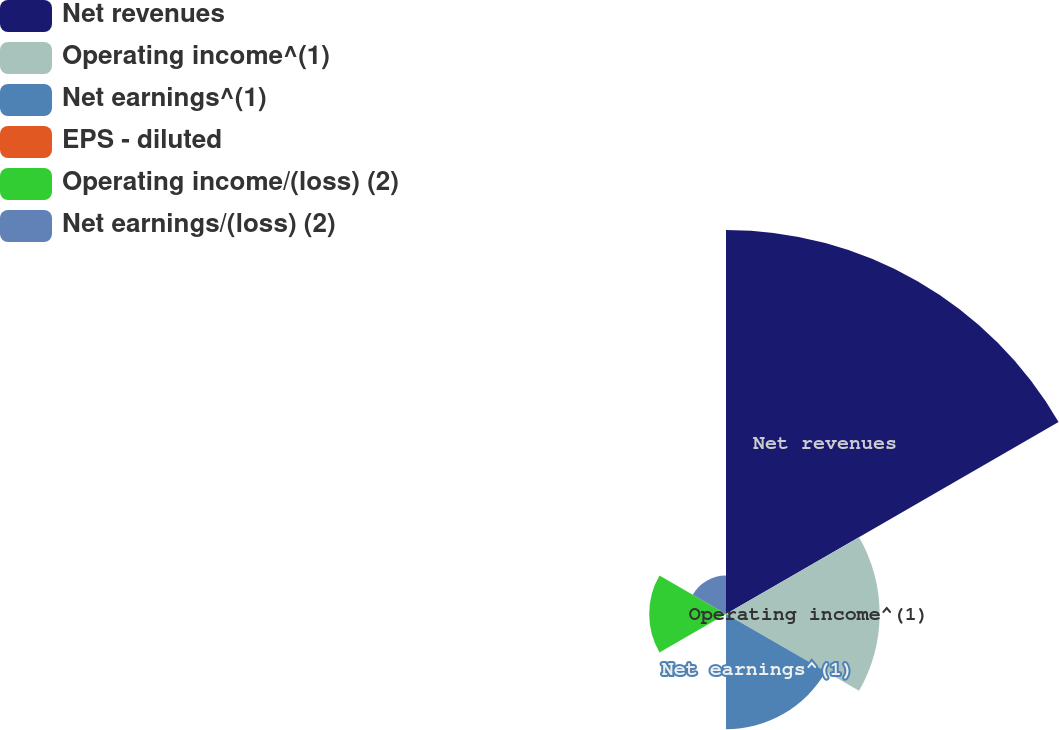Convert chart to OTSL. <chart><loc_0><loc_0><loc_500><loc_500><pie_chart><fcel>Net revenues<fcel>Operating income^(1)<fcel>Net earnings^(1)<fcel>EPS - diluted<fcel>Operating income/(loss) (2)<fcel>Net earnings/(loss) (2)<nl><fcel>49.99%<fcel>20.0%<fcel>15.0%<fcel>0.0%<fcel>10.0%<fcel>5.0%<nl></chart> 